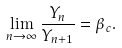<formula> <loc_0><loc_0><loc_500><loc_500>\lim _ { n \rightarrow \infty } \frac { Y _ { n } } { Y _ { n + 1 } } = \beta _ { c } .</formula> 